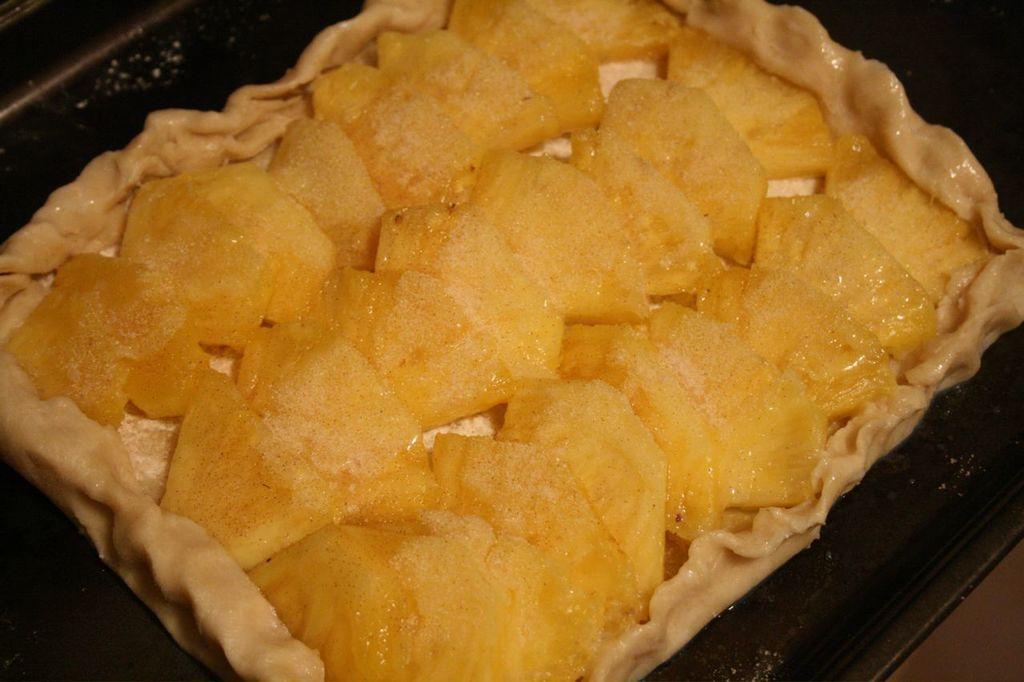In one or two sentences, can you explain what this image depicts? In this image there is some food on the plate. 